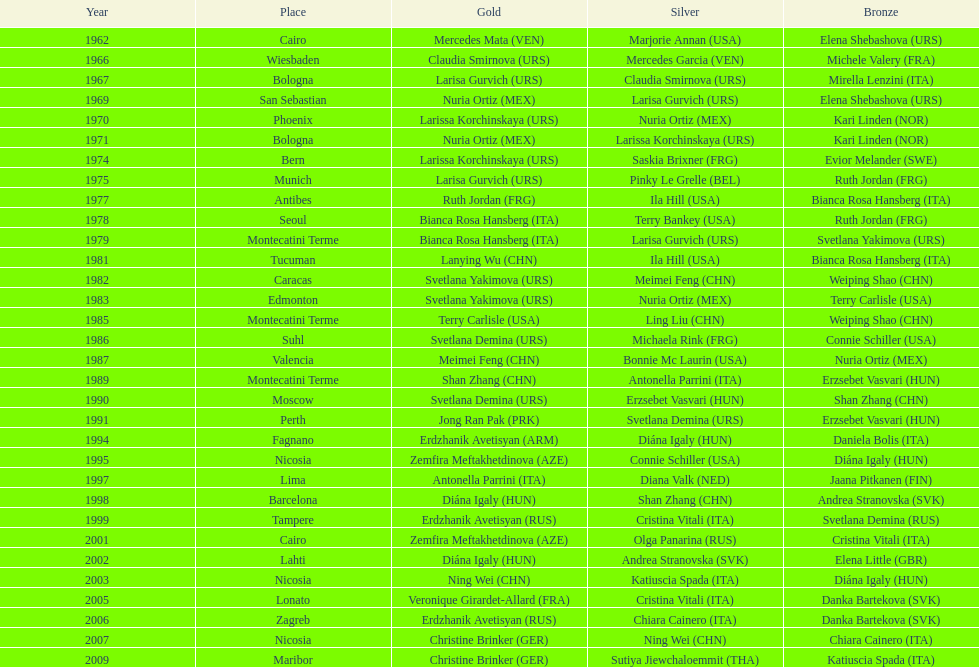Who claimed the exclusive gold medal in 1962? Mercedes Mata. 